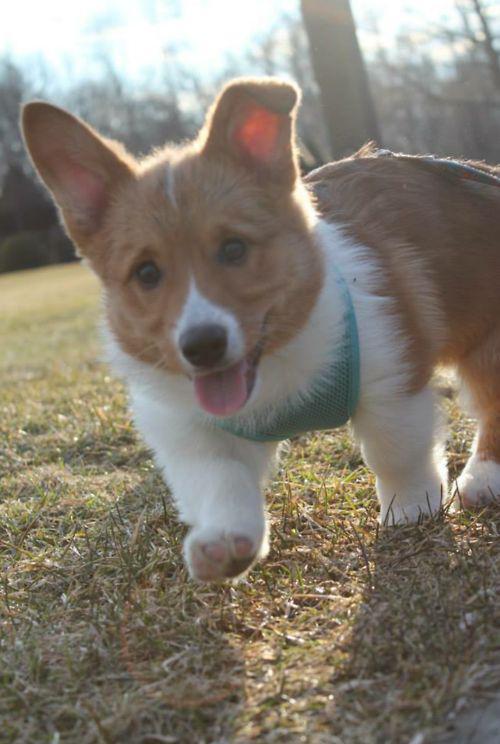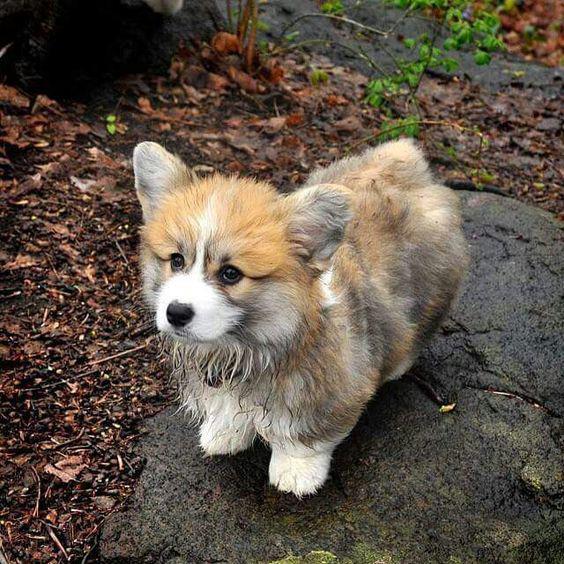The first image is the image on the left, the second image is the image on the right. Considering the images on both sides, is "There are three dogs in the right image." valid? Answer yes or no. No. The first image is the image on the left, the second image is the image on the right. Given the left and right images, does the statement "There are four dogs." hold true? Answer yes or no. No. 